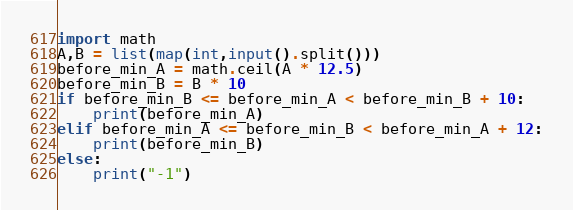<code> <loc_0><loc_0><loc_500><loc_500><_Python_>import math
A,B = list(map(int,input().split()))
before_min_A = math.ceil(A * 12.5)
before_min_B = B * 10
if before_min_B <= before_min_A < before_min_B + 10:
    print(before_min_A)
elif before_min_A <= before_min_B < before_min_A + 12:
    print(before_min_B)
else:
    print("-1")</code> 